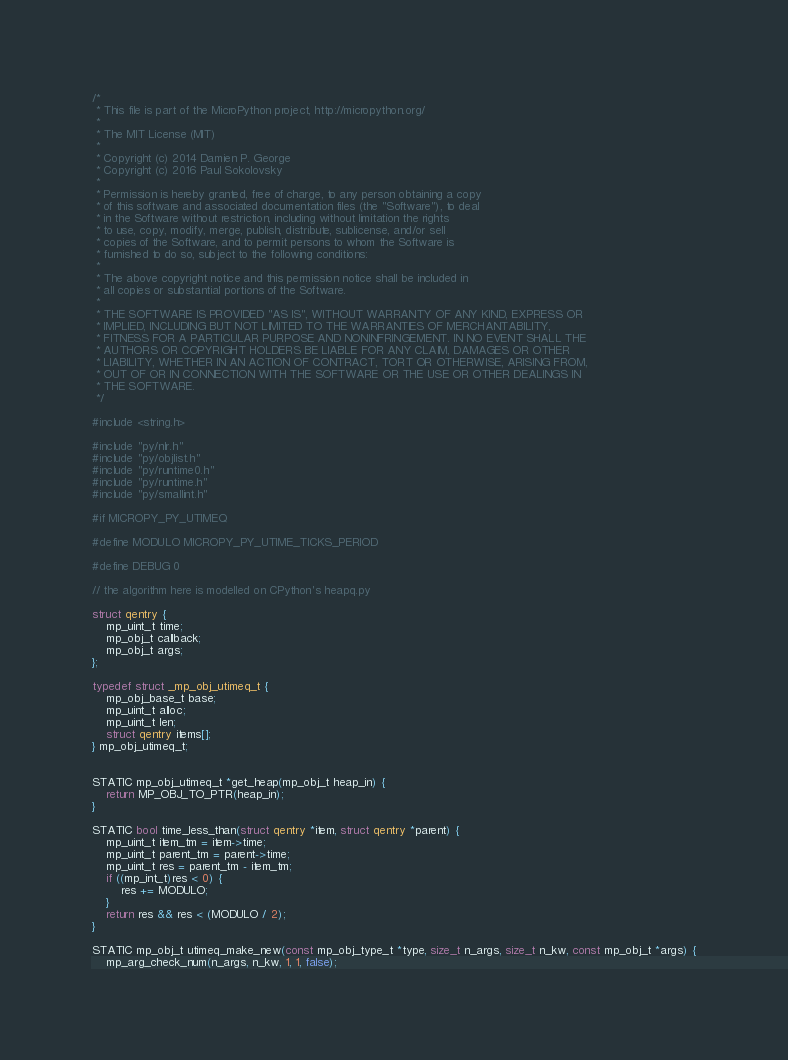Convert code to text. <code><loc_0><loc_0><loc_500><loc_500><_C_>/*
 * This file is part of the MicroPython project, http://micropython.org/
 *
 * The MIT License (MIT)
 *
 * Copyright (c) 2014 Damien P. George
 * Copyright (c) 2016 Paul Sokolovsky
 *
 * Permission is hereby granted, free of charge, to any person obtaining a copy
 * of this software and associated documentation files (the "Software"), to deal
 * in the Software without restriction, including without limitation the rights
 * to use, copy, modify, merge, publish, distribute, sublicense, and/or sell
 * copies of the Software, and to permit persons to whom the Software is
 * furnished to do so, subject to the following conditions:
 *
 * The above copyright notice and this permission notice shall be included in
 * all copies or substantial portions of the Software.
 *
 * THE SOFTWARE IS PROVIDED "AS IS", WITHOUT WARRANTY OF ANY KIND, EXPRESS OR
 * IMPLIED, INCLUDING BUT NOT LIMITED TO THE WARRANTIES OF MERCHANTABILITY,
 * FITNESS FOR A PARTICULAR PURPOSE AND NONINFRINGEMENT. IN NO EVENT SHALL THE
 * AUTHORS OR COPYRIGHT HOLDERS BE LIABLE FOR ANY CLAIM, DAMAGES OR OTHER
 * LIABILITY, WHETHER IN AN ACTION OF CONTRACT, TORT OR OTHERWISE, ARISING FROM,
 * OUT OF OR IN CONNECTION WITH THE SOFTWARE OR THE USE OR OTHER DEALINGS IN
 * THE SOFTWARE.
 */

#include <string.h>

#include "py/nlr.h"
#include "py/objlist.h"
#include "py/runtime0.h"
#include "py/runtime.h"
#include "py/smallint.h"

#if MICROPY_PY_UTIMEQ

#define MODULO MICROPY_PY_UTIME_TICKS_PERIOD

#define DEBUG 0

// the algorithm here is modelled on CPython's heapq.py

struct qentry {
    mp_uint_t time;
    mp_obj_t callback;
    mp_obj_t args;
};

typedef struct _mp_obj_utimeq_t {
    mp_obj_base_t base;
    mp_uint_t alloc;
    mp_uint_t len;
    struct qentry items[];
} mp_obj_utimeq_t;


STATIC mp_obj_utimeq_t *get_heap(mp_obj_t heap_in) {
    return MP_OBJ_TO_PTR(heap_in);
}

STATIC bool time_less_than(struct qentry *item, struct qentry *parent) {
    mp_uint_t item_tm = item->time;
    mp_uint_t parent_tm = parent->time;
    mp_uint_t res = parent_tm - item_tm;
    if ((mp_int_t)res < 0) {
        res += MODULO;
    }
    return res && res < (MODULO / 2);
}

STATIC mp_obj_t utimeq_make_new(const mp_obj_type_t *type, size_t n_args, size_t n_kw, const mp_obj_t *args) {
    mp_arg_check_num(n_args, n_kw, 1, 1, false);</code> 